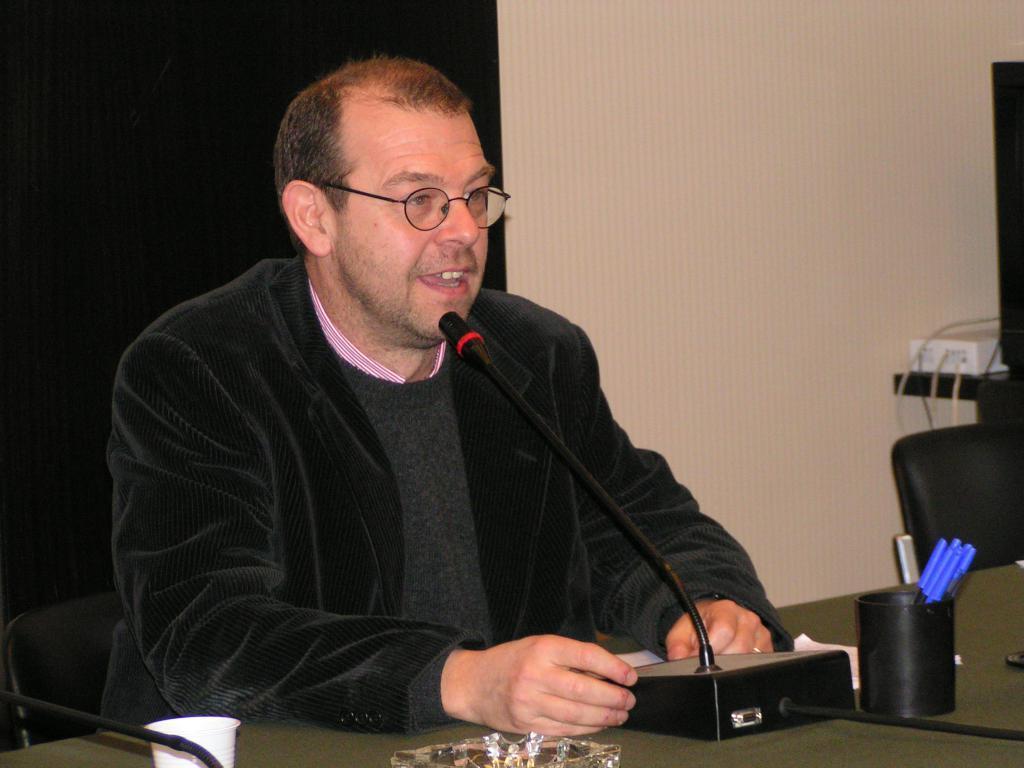Please provide a concise description of this image. In this image there is a man sitting in chair in front of table speaking on a microphone, beside that there is a stand with pens, cup, ash tray and cables connected to socket. 